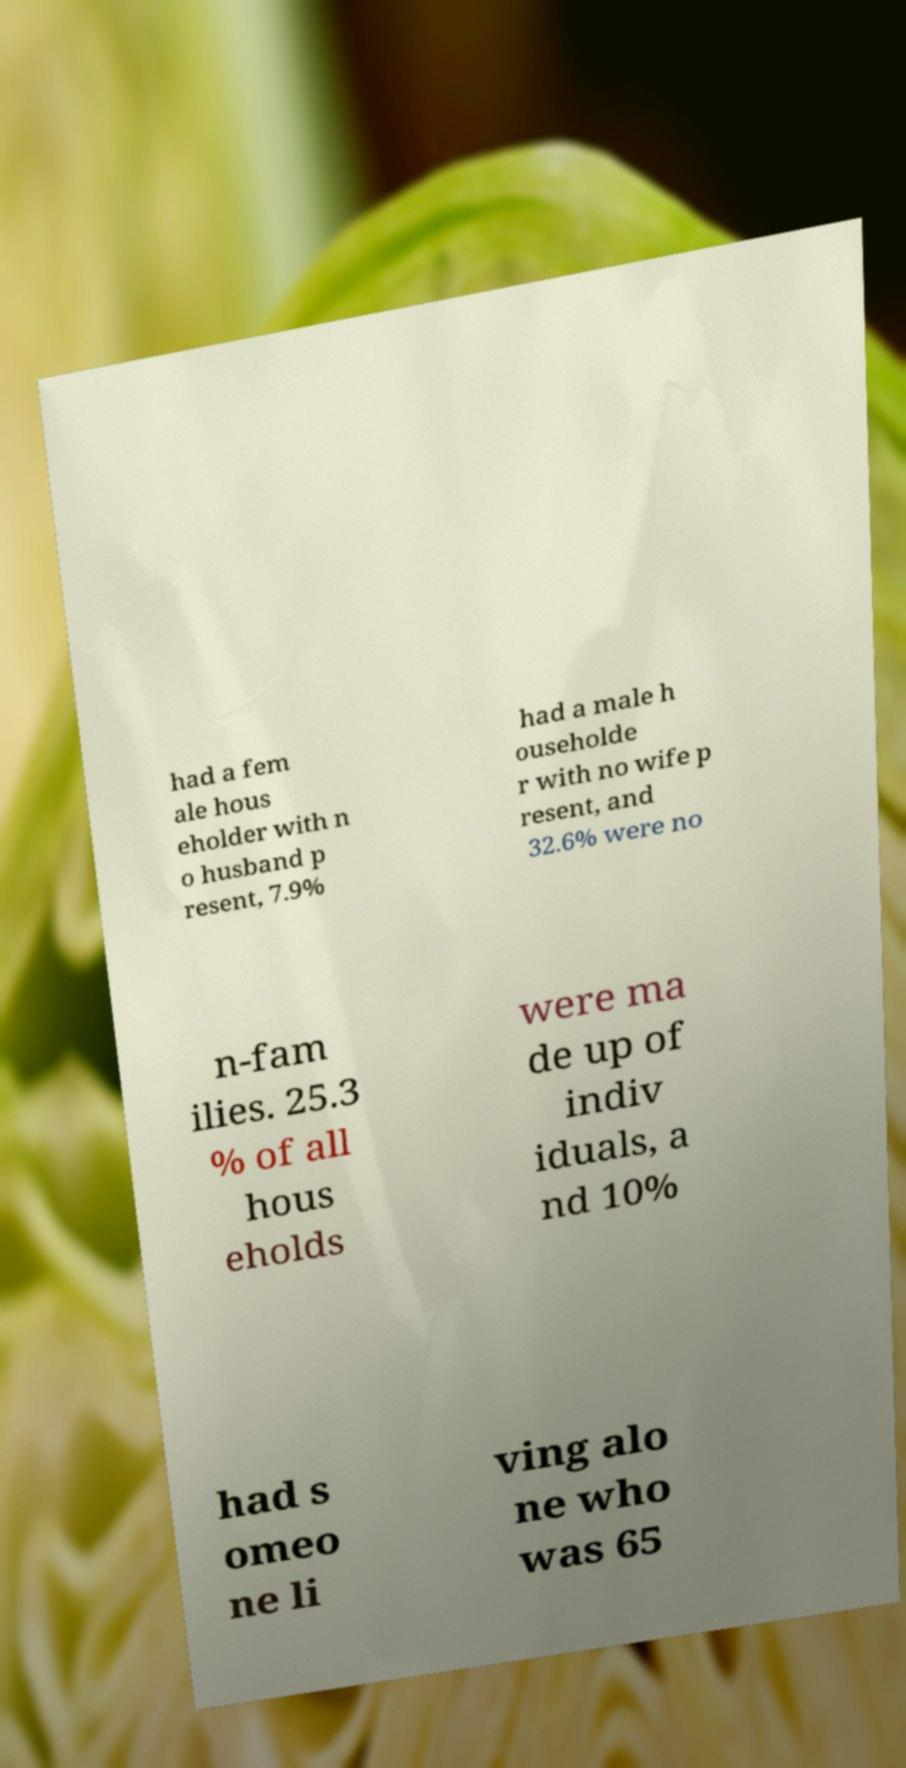Can you read and provide the text displayed in the image?This photo seems to have some interesting text. Can you extract and type it out for me? had a fem ale hous eholder with n o husband p resent, 7.9% had a male h ouseholde r with no wife p resent, and 32.6% were no n-fam ilies. 25.3 % of all hous eholds were ma de up of indiv iduals, a nd 10% had s omeo ne li ving alo ne who was 65 